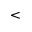<formula> <loc_0><loc_0><loc_500><loc_500><</formula> 